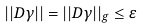<formula> <loc_0><loc_0><loc_500><loc_500>| | D \gamma | | = | | D \gamma | | _ { g } \leq \varepsilon</formula> 